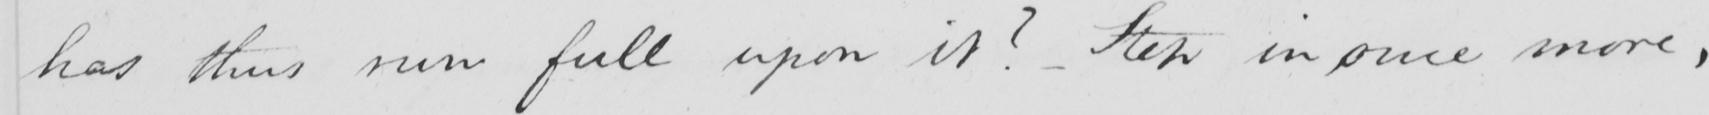Please provide the text content of this handwritten line. has thus run full upon it ?   _  Step in once more , 